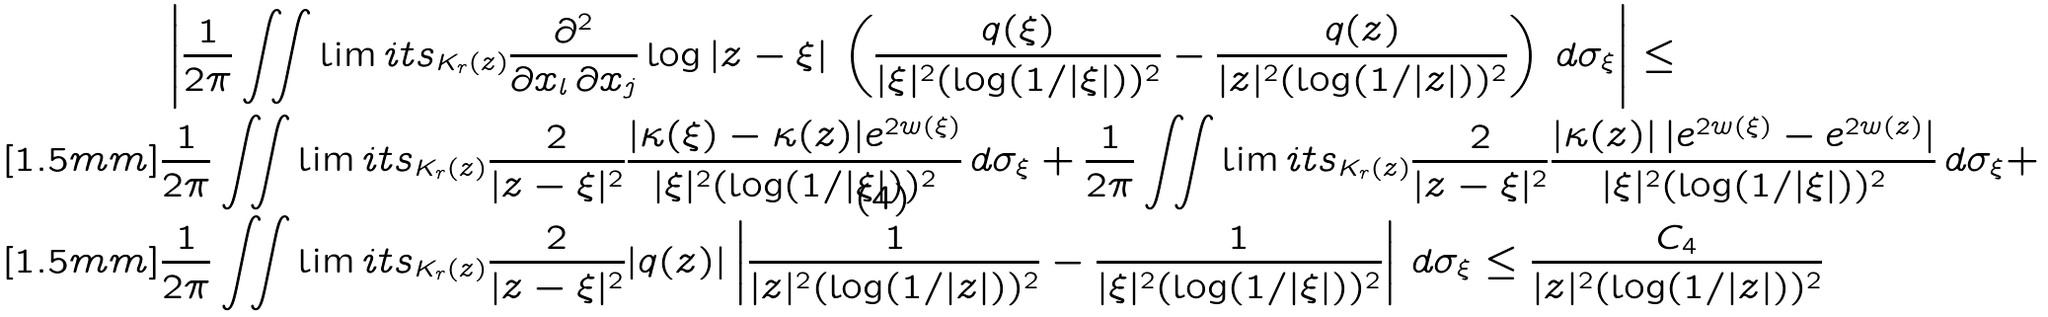Convert formula to latex. <formula><loc_0><loc_0><loc_500><loc_500>& \left | \frac { 1 } { 2 \pi } \iint \lim i t s _ { K _ { r } ( z ) } \frac { \partial ^ { 2 } } { \partial x _ { l } \, \partial x _ { j } } \log | z - \xi | \, \left ( \frac { q ( \xi ) } { | \xi | ^ { 2 } ( \log ( 1 / | \xi | ) ) ^ { 2 } } - \frac { q ( z ) } { | z | ^ { 2 } ( \log ( 1 / | z | ) ) ^ { 2 } } \right ) \, d \sigma _ { \xi } \right | \leq \\ [ 1 . 5 m m ] & \frac { 1 } { 2 \pi } \iint \lim i t s _ { K _ { r } ( z ) } \frac { 2 } { | z - \xi | ^ { 2 } } \frac { | \kappa ( \xi ) - \kappa ( z ) | e ^ { 2 w ( \xi ) } } { | \xi | ^ { 2 } ( \log ( 1 / | \xi | ) ) ^ { 2 } } \, d \sigma _ { \xi } + \frac { 1 } { 2 \pi } \iint \lim i t s _ { K _ { r } ( z ) } \frac { 2 } { | z - \xi | ^ { 2 } } \frac { | \kappa ( z ) | \, | e ^ { 2 w ( \xi ) } - e ^ { 2 w ( z ) } | } { | \xi | ^ { 2 } ( \log ( 1 / | \xi | ) ) ^ { 2 } } \, d \sigma _ { \xi } + \\ [ 1 . 5 m m ] & \frac { 1 } { 2 \pi } \iint \lim i t s _ { K _ { r } ( z ) } \frac { 2 } { | z - \xi | ^ { 2 } } | q ( z ) | \left | \frac { 1 } { | z | ^ { 2 } ( \log ( 1 / | z | ) ) ^ { 2 } } - \frac { 1 } { | \xi | ^ { 2 } ( \log ( 1 / | \xi | ) ) ^ { 2 } } \right | \, d \sigma _ { \xi } \leq \frac { C _ { 4 } } { | z | ^ { 2 } ( \log ( 1 / | z | ) ) ^ { 2 } }</formula> 